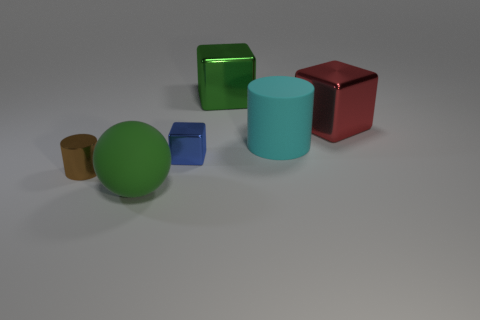How many other objects are the same color as the big matte sphere?
Provide a short and direct response. 1. How many things are either large shiny things on the right side of the big rubber cylinder or metallic objects behind the large red block?
Provide a short and direct response. 2. Are there any brown metallic things of the same shape as the cyan object?
Offer a terse response. Yes. What is the material of the large cube that is the same color as the ball?
Offer a terse response. Metal. What number of metal objects are large red blocks or big green balls?
Offer a terse response. 1. The cyan object has what shape?
Provide a succinct answer. Cylinder. What number of big cyan cylinders are made of the same material as the blue thing?
Provide a succinct answer. 0. There is a object that is the same material as the ball; what color is it?
Ensure brevity in your answer.  Cyan. There is a cube on the left side of the green metallic thing; does it have the same size as the large green ball?
Keep it short and to the point. No. There is another large thing that is the same shape as the brown object; what is its color?
Your answer should be very brief. Cyan. 